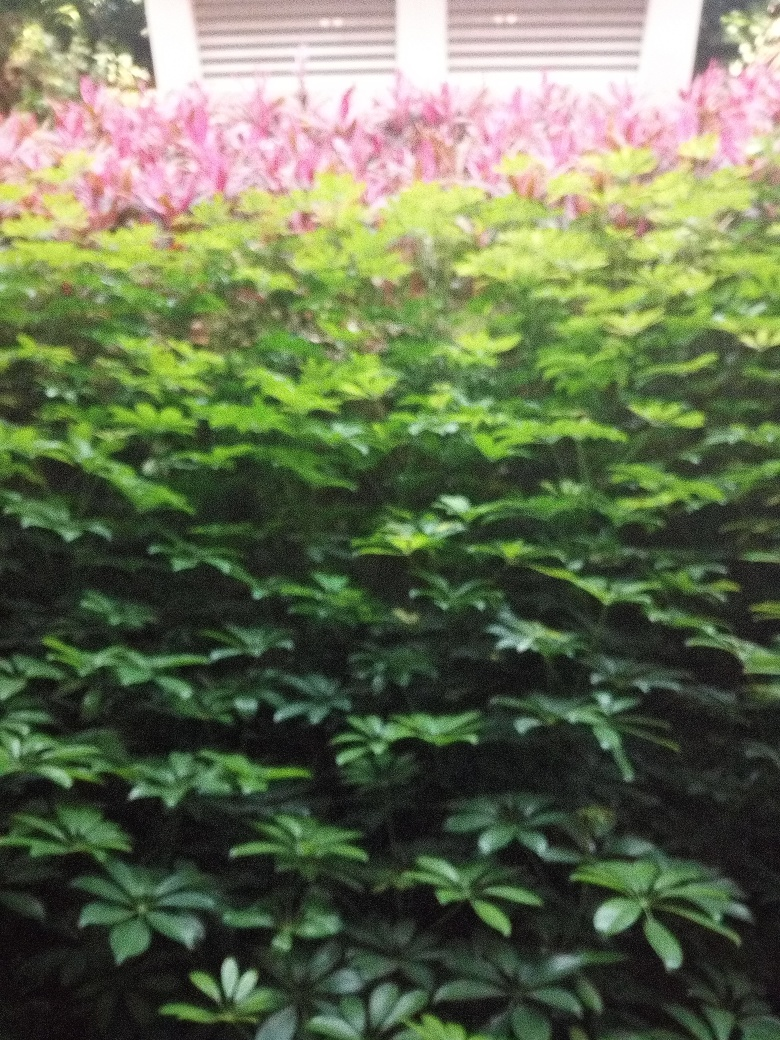Is there heavy graininess in the image? Yes, the image exhibits a noticeable level of graininess, reducing the overall sharpness and clarity, which suggests it may have been taken in low lighting conditions or with a high ISO setting on the camera. 